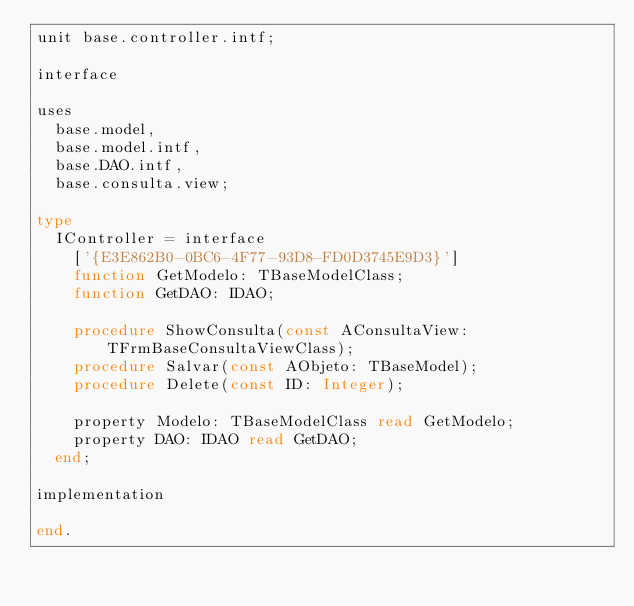Convert code to text. <code><loc_0><loc_0><loc_500><loc_500><_Pascal_>unit base.controller.intf;

interface

uses
  base.model,
  base.model.intf,
  base.DAO.intf,
  base.consulta.view;

type
  IController = interface
    ['{E3E862B0-0BC6-4F77-93D8-FD0D3745E9D3}']
    function GetModelo: TBaseModelClass;
    function GetDAO: IDAO;

    procedure ShowConsulta(const AConsultaView: TFrmBaseConsultaViewClass);
    procedure Salvar(const AObjeto: TBaseModel);
    procedure Delete(const ID: Integer);

    property Modelo: TBaseModelClass read GetModelo;
    property DAO: IDAO read GetDAO;
  end;

implementation

end.
</code> 